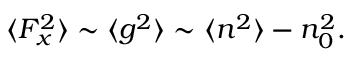<formula> <loc_0><loc_0><loc_500><loc_500>\begin{array} { r } { \langle F _ { x } ^ { 2 } \rangle \sim \langle g ^ { 2 } \rangle \sim \langle n ^ { 2 } \rangle - n _ { 0 } ^ { 2 } . } \end{array}</formula> 